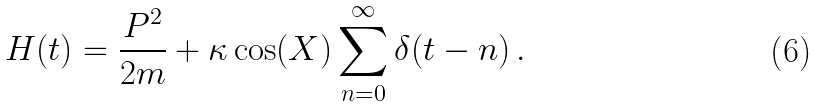Convert formula to latex. <formula><loc_0><loc_0><loc_500><loc_500>H ( t ) = \frac { P ^ { 2 } } { 2 m } + \kappa \cos ( X ) \sum _ { n = 0 } ^ { \infty } \delta ( t - n ) \, .</formula> 